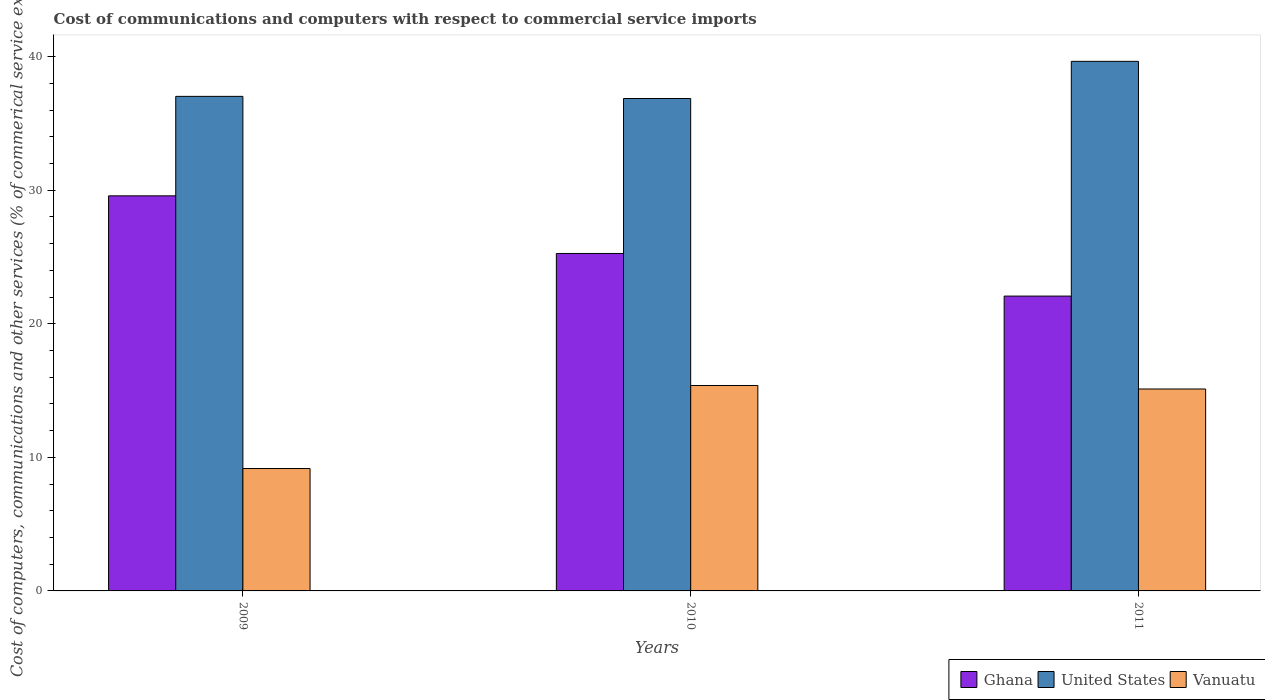How many different coloured bars are there?
Your answer should be compact. 3. How many groups of bars are there?
Keep it short and to the point. 3. Are the number of bars per tick equal to the number of legend labels?
Your answer should be compact. Yes. Are the number of bars on each tick of the X-axis equal?
Provide a short and direct response. Yes. What is the label of the 3rd group of bars from the left?
Ensure brevity in your answer.  2011. In how many cases, is the number of bars for a given year not equal to the number of legend labels?
Offer a terse response. 0. What is the cost of communications and computers in United States in 2011?
Your answer should be compact. 39.65. Across all years, what is the maximum cost of communications and computers in Ghana?
Keep it short and to the point. 29.58. Across all years, what is the minimum cost of communications and computers in Vanuatu?
Give a very brief answer. 9.16. What is the total cost of communications and computers in Vanuatu in the graph?
Offer a very short reply. 39.66. What is the difference between the cost of communications and computers in United States in 2010 and that in 2011?
Your answer should be compact. -2.78. What is the difference between the cost of communications and computers in Ghana in 2011 and the cost of communications and computers in United States in 2010?
Keep it short and to the point. -14.79. What is the average cost of communications and computers in United States per year?
Offer a very short reply. 37.85. In the year 2010, what is the difference between the cost of communications and computers in Vanuatu and cost of communications and computers in Ghana?
Your answer should be very brief. -9.88. In how many years, is the cost of communications and computers in Ghana greater than 20 %?
Offer a very short reply. 3. What is the ratio of the cost of communications and computers in Ghana in 2009 to that in 2011?
Provide a succinct answer. 1.34. Is the cost of communications and computers in Ghana in 2009 less than that in 2010?
Provide a succinct answer. No. Is the difference between the cost of communications and computers in Vanuatu in 2009 and 2010 greater than the difference between the cost of communications and computers in Ghana in 2009 and 2010?
Give a very brief answer. No. What is the difference between the highest and the second highest cost of communications and computers in Vanuatu?
Offer a terse response. 0.26. What is the difference between the highest and the lowest cost of communications and computers in Ghana?
Provide a succinct answer. 7.51. What does the 3rd bar from the left in 2011 represents?
Provide a succinct answer. Vanuatu. What does the 1st bar from the right in 2010 represents?
Your response must be concise. Vanuatu. How many years are there in the graph?
Provide a short and direct response. 3. Does the graph contain any zero values?
Offer a very short reply. No. How are the legend labels stacked?
Your response must be concise. Horizontal. What is the title of the graph?
Offer a very short reply. Cost of communications and computers with respect to commercial service imports. Does "Heavily indebted poor countries" appear as one of the legend labels in the graph?
Give a very brief answer. No. What is the label or title of the Y-axis?
Offer a terse response. Cost of computers, communications and other services (% of commerical service exports). What is the Cost of computers, communications and other services (% of commerical service exports) of Ghana in 2009?
Your answer should be compact. 29.58. What is the Cost of computers, communications and other services (% of commerical service exports) in United States in 2009?
Provide a succinct answer. 37.03. What is the Cost of computers, communications and other services (% of commerical service exports) of Vanuatu in 2009?
Give a very brief answer. 9.16. What is the Cost of computers, communications and other services (% of commerical service exports) of Ghana in 2010?
Keep it short and to the point. 25.26. What is the Cost of computers, communications and other services (% of commerical service exports) in United States in 2010?
Make the answer very short. 36.87. What is the Cost of computers, communications and other services (% of commerical service exports) of Vanuatu in 2010?
Keep it short and to the point. 15.38. What is the Cost of computers, communications and other services (% of commerical service exports) of Ghana in 2011?
Your answer should be very brief. 22.07. What is the Cost of computers, communications and other services (% of commerical service exports) in United States in 2011?
Your response must be concise. 39.65. What is the Cost of computers, communications and other services (% of commerical service exports) of Vanuatu in 2011?
Keep it short and to the point. 15.12. Across all years, what is the maximum Cost of computers, communications and other services (% of commerical service exports) of Ghana?
Your response must be concise. 29.58. Across all years, what is the maximum Cost of computers, communications and other services (% of commerical service exports) of United States?
Ensure brevity in your answer.  39.65. Across all years, what is the maximum Cost of computers, communications and other services (% of commerical service exports) in Vanuatu?
Provide a succinct answer. 15.38. Across all years, what is the minimum Cost of computers, communications and other services (% of commerical service exports) of Ghana?
Keep it short and to the point. 22.07. Across all years, what is the minimum Cost of computers, communications and other services (% of commerical service exports) in United States?
Ensure brevity in your answer.  36.87. Across all years, what is the minimum Cost of computers, communications and other services (% of commerical service exports) in Vanuatu?
Ensure brevity in your answer.  9.16. What is the total Cost of computers, communications and other services (% of commerical service exports) in Ghana in the graph?
Your answer should be very brief. 76.92. What is the total Cost of computers, communications and other services (% of commerical service exports) in United States in the graph?
Ensure brevity in your answer.  113.54. What is the total Cost of computers, communications and other services (% of commerical service exports) in Vanuatu in the graph?
Ensure brevity in your answer.  39.66. What is the difference between the Cost of computers, communications and other services (% of commerical service exports) in Ghana in 2009 and that in 2010?
Your response must be concise. 4.32. What is the difference between the Cost of computers, communications and other services (% of commerical service exports) of United States in 2009 and that in 2010?
Your answer should be compact. 0.16. What is the difference between the Cost of computers, communications and other services (% of commerical service exports) in Vanuatu in 2009 and that in 2010?
Make the answer very short. -6.22. What is the difference between the Cost of computers, communications and other services (% of commerical service exports) in Ghana in 2009 and that in 2011?
Ensure brevity in your answer.  7.51. What is the difference between the Cost of computers, communications and other services (% of commerical service exports) of United States in 2009 and that in 2011?
Keep it short and to the point. -2.62. What is the difference between the Cost of computers, communications and other services (% of commerical service exports) in Vanuatu in 2009 and that in 2011?
Your response must be concise. -5.95. What is the difference between the Cost of computers, communications and other services (% of commerical service exports) in Ghana in 2010 and that in 2011?
Your answer should be compact. 3.19. What is the difference between the Cost of computers, communications and other services (% of commerical service exports) of United States in 2010 and that in 2011?
Make the answer very short. -2.78. What is the difference between the Cost of computers, communications and other services (% of commerical service exports) of Vanuatu in 2010 and that in 2011?
Keep it short and to the point. 0.26. What is the difference between the Cost of computers, communications and other services (% of commerical service exports) in Ghana in 2009 and the Cost of computers, communications and other services (% of commerical service exports) in United States in 2010?
Your answer should be very brief. -7.29. What is the difference between the Cost of computers, communications and other services (% of commerical service exports) in Ghana in 2009 and the Cost of computers, communications and other services (% of commerical service exports) in Vanuatu in 2010?
Make the answer very short. 14.2. What is the difference between the Cost of computers, communications and other services (% of commerical service exports) of United States in 2009 and the Cost of computers, communications and other services (% of commerical service exports) of Vanuatu in 2010?
Give a very brief answer. 21.65. What is the difference between the Cost of computers, communications and other services (% of commerical service exports) in Ghana in 2009 and the Cost of computers, communications and other services (% of commerical service exports) in United States in 2011?
Provide a short and direct response. -10.07. What is the difference between the Cost of computers, communications and other services (% of commerical service exports) of Ghana in 2009 and the Cost of computers, communications and other services (% of commerical service exports) of Vanuatu in 2011?
Provide a short and direct response. 14.46. What is the difference between the Cost of computers, communications and other services (% of commerical service exports) in United States in 2009 and the Cost of computers, communications and other services (% of commerical service exports) in Vanuatu in 2011?
Make the answer very short. 21.91. What is the difference between the Cost of computers, communications and other services (% of commerical service exports) in Ghana in 2010 and the Cost of computers, communications and other services (% of commerical service exports) in United States in 2011?
Provide a short and direct response. -14.38. What is the difference between the Cost of computers, communications and other services (% of commerical service exports) in Ghana in 2010 and the Cost of computers, communications and other services (% of commerical service exports) in Vanuatu in 2011?
Provide a short and direct response. 10.15. What is the difference between the Cost of computers, communications and other services (% of commerical service exports) in United States in 2010 and the Cost of computers, communications and other services (% of commerical service exports) in Vanuatu in 2011?
Provide a succinct answer. 21.75. What is the average Cost of computers, communications and other services (% of commerical service exports) in Ghana per year?
Ensure brevity in your answer.  25.64. What is the average Cost of computers, communications and other services (% of commerical service exports) in United States per year?
Give a very brief answer. 37.85. What is the average Cost of computers, communications and other services (% of commerical service exports) of Vanuatu per year?
Your response must be concise. 13.22. In the year 2009, what is the difference between the Cost of computers, communications and other services (% of commerical service exports) of Ghana and Cost of computers, communications and other services (% of commerical service exports) of United States?
Give a very brief answer. -7.45. In the year 2009, what is the difference between the Cost of computers, communications and other services (% of commerical service exports) of Ghana and Cost of computers, communications and other services (% of commerical service exports) of Vanuatu?
Offer a terse response. 20.42. In the year 2009, what is the difference between the Cost of computers, communications and other services (% of commerical service exports) in United States and Cost of computers, communications and other services (% of commerical service exports) in Vanuatu?
Keep it short and to the point. 27.86. In the year 2010, what is the difference between the Cost of computers, communications and other services (% of commerical service exports) of Ghana and Cost of computers, communications and other services (% of commerical service exports) of United States?
Provide a succinct answer. -11.6. In the year 2010, what is the difference between the Cost of computers, communications and other services (% of commerical service exports) in Ghana and Cost of computers, communications and other services (% of commerical service exports) in Vanuatu?
Your answer should be very brief. 9.88. In the year 2010, what is the difference between the Cost of computers, communications and other services (% of commerical service exports) of United States and Cost of computers, communications and other services (% of commerical service exports) of Vanuatu?
Your response must be concise. 21.49. In the year 2011, what is the difference between the Cost of computers, communications and other services (% of commerical service exports) in Ghana and Cost of computers, communications and other services (% of commerical service exports) in United States?
Keep it short and to the point. -17.57. In the year 2011, what is the difference between the Cost of computers, communications and other services (% of commerical service exports) of Ghana and Cost of computers, communications and other services (% of commerical service exports) of Vanuatu?
Offer a terse response. 6.96. In the year 2011, what is the difference between the Cost of computers, communications and other services (% of commerical service exports) of United States and Cost of computers, communications and other services (% of commerical service exports) of Vanuatu?
Make the answer very short. 24.53. What is the ratio of the Cost of computers, communications and other services (% of commerical service exports) in Ghana in 2009 to that in 2010?
Offer a terse response. 1.17. What is the ratio of the Cost of computers, communications and other services (% of commerical service exports) of United States in 2009 to that in 2010?
Keep it short and to the point. 1. What is the ratio of the Cost of computers, communications and other services (% of commerical service exports) in Vanuatu in 2009 to that in 2010?
Provide a short and direct response. 0.6. What is the ratio of the Cost of computers, communications and other services (% of commerical service exports) of Ghana in 2009 to that in 2011?
Offer a very short reply. 1.34. What is the ratio of the Cost of computers, communications and other services (% of commerical service exports) of United States in 2009 to that in 2011?
Offer a terse response. 0.93. What is the ratio of the Cost of computers, communications and other services (% of commerical service exports) in Vanuatu in 2009 to that in 2011?
Provide a short and direct response. 0.61. What is the ratio of the Cost of computers, communications and other services (% of commerical service exports) in Ghana in 2010 to that in 2011?
Your answer should be compact. 1.14. What is the ratio of the Cost of computers, communications and other services (% of commerical service exports) in United States in 2010 to that in 2011?
Offer a very short reply. 0.93. What is the ratio of the Cost of computers, communications and other services (% of commerical service exports) in Vanuatu in 2010 to that in 2011?
Provide a succinct answer. 1.02. What is the difference between the highest and the second highest Cost of computers, communications and other services (% of commerical service exports) of Ghana?
Your response must be concise. 4.32. What is the difference between the highest and the second highest Cost of computers, communications and other services (% of commerical service exports) in United States?
Provide a succinct answer. 2.62. What is the difference between the highest and the second highest Cost of computers, communications and other services (% of commerical service exports) in Vanuatu?
Your answer should be very brief. 0.26. What is the difference between the highest and the lowest Cost of computers, communications and other services (% of commerical service exports) of Ghana?
Provide a succinct answer. 7.51. What is the difference between the highest and the lowest Cost of computers, communications and other services (% of commerical service exports) in United States?
Make the answer very short. 2.78. What is the difference between the highest and the lowest Cost of computers, communications and other services (% of commerical service exports) in Vanuatu?
Your response must be concise. 6.22. 